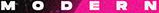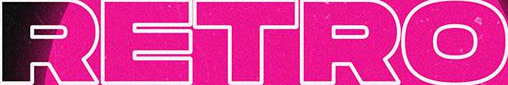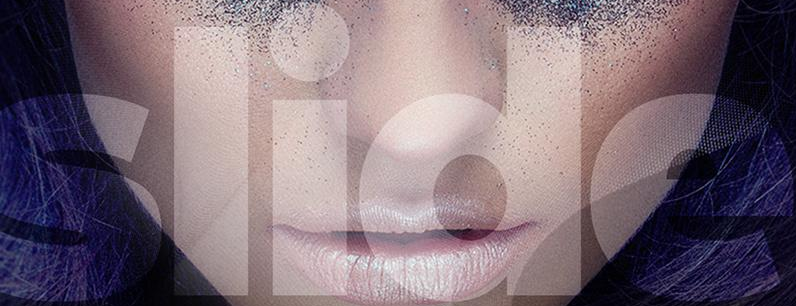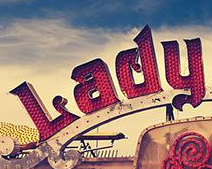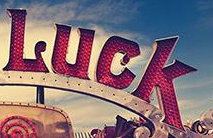Read the text content from these images in order, separated by a semicolon. MODERN; RETRO; slide; Lady; Luck 